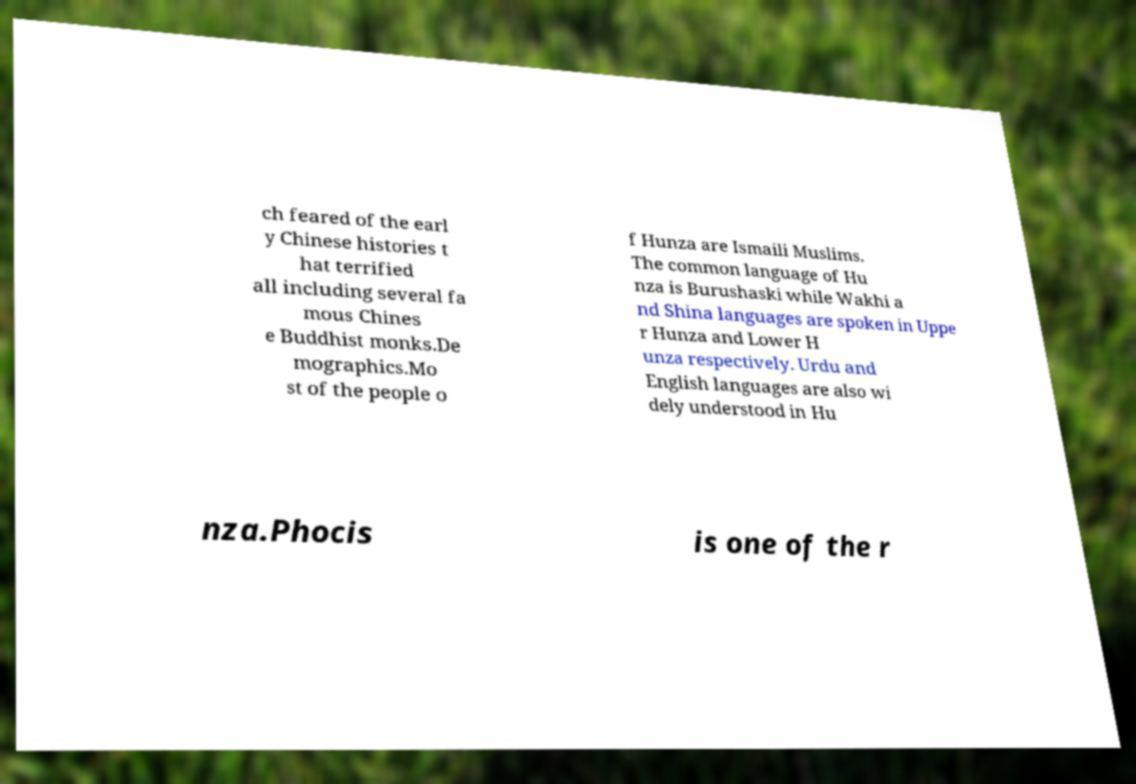What messages or text are displayed in this image? I need them in a readable, typed format. ch feared of the earl y Chinese histories t hat terrified all including several fa mous Chines e Buddhist monks.De mographics.Mo st of the people o f Hunza are Ismaili Muslims. The common language of Hu nza is Burushaski while Wakhi a nd Shina languages are spoken in Uppe r Hunza and Lower H unza respectively. Urdu and English languages are also wi dely understood in Hu nza.Phocis is one of the r 